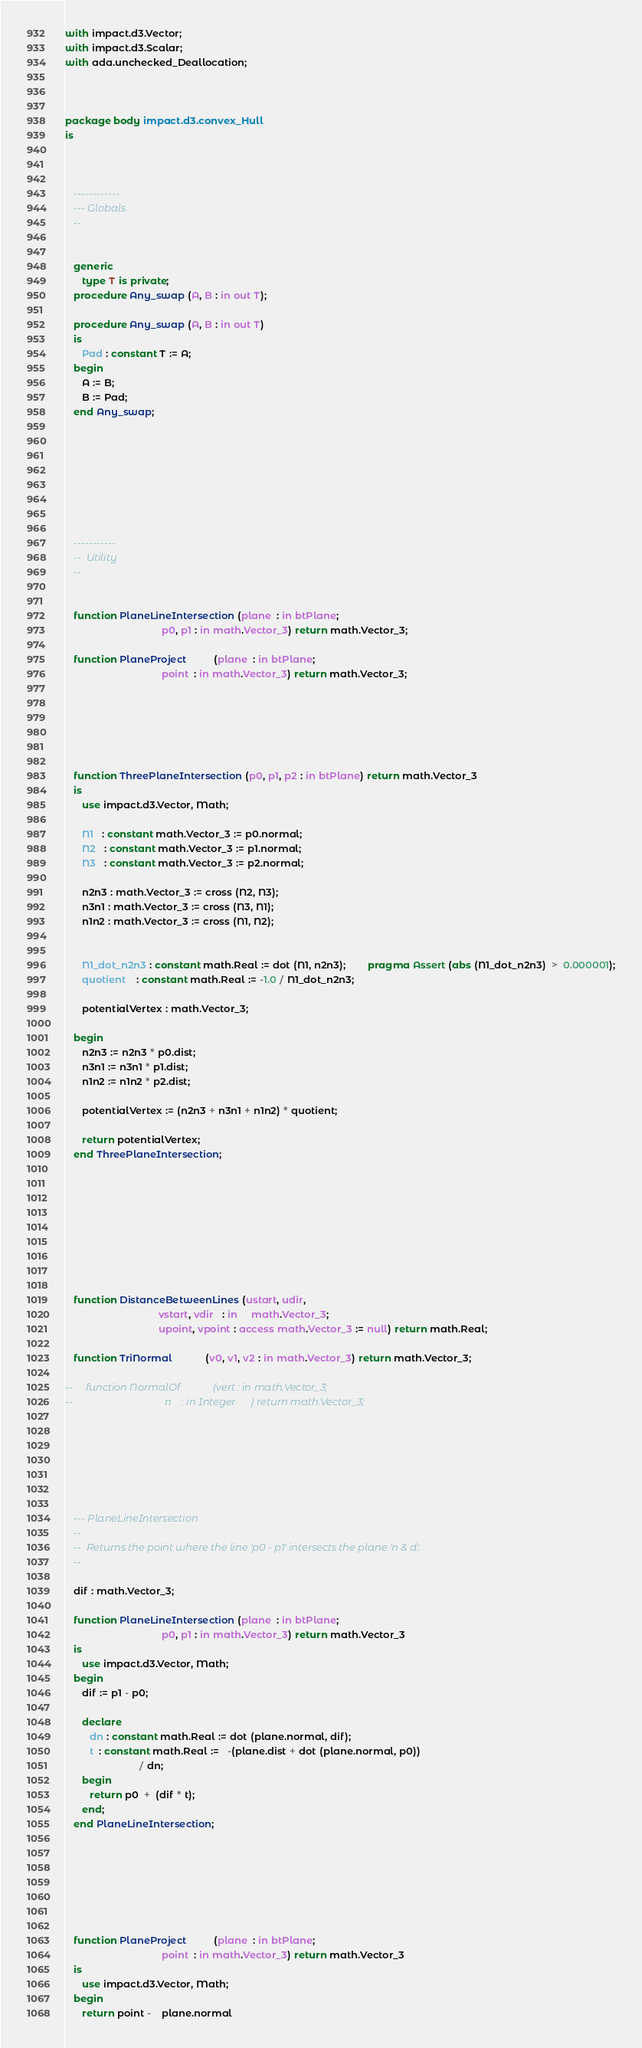Convert code to text. <code><loc_0><loc_0><loc_500><loc_500><_Ada_>with impact.d3.Vector;
with impact.d3.Scalar;
with ada.unchecked_Deallocation;



package body impact.d3.convex_Hull
is



   ------------
   --- Globals
   --


   generic
      type T is private;
   procedure Any_swap (A, B : in out T);

   procedure Any_swap (A, B : in out T)
   is
      Pad : constant T := A;
   begin
      A := B;
      B := Pad;
   end Any_swap;








   -----------
   --  Utility
   --


   function PlaneLineIntersection (plane  : in btPlane;
                                   p0, p1 : in math.Vector_3) return math.Vector_3;

   function PlaneProject          (plane  : in btPlane;
                                   point  : in math.Vector_3) return math.Vector_3;






   function ThreePlaneIntersection (p0, p1, p2 : in btPlane) return math.Vector_3
   is
      use impact.d3.Vector, Math;

      N1   : constant math.Vector_3 := p0.normal;
      N2   : constant math.Vector_3 := p1.normal;
      N3   : constant math.Vector_3 := p2.normal;

      n2n3 : math.Vector_3 := cross (N2, N3);
      n3n1 : math.Vector_3 := cross (N3, N1);
      n1n2 : math.Vector_3 := cross (N1, N2);


      N1_dot_n2n3 : constant math.Real := dot (N1, n2n3);        pragma Assert (abs (N1_dot_n2n3)  >  0.000001);
      quotient    : constant math.Real := -1.0 / N1_dot_n2n3;

      potentialVertex : math.Vector_3;

   begin
      n2n3 := n2n3 * p0.dist;
      n3n1 := n3n1 * p1.dist;
      n1n2 := n1n2 * p2.dist;

      potentialVertex := (n2n3 + n3n1 + n1n2) * quotient;

      return potentialVertex;
   end ThreePlaneIntersection;









   function DistanceBetweenLines (ustart, udir,
                                  vstart, vdir   : in     math.Vector_3;
                                  upoint, vpoint : access math.Vector_3 := null) return math.Real;

   function TriNormal            (v0, v1, v2 : in math.Vector_3) return math.Vector_3;

--     function NormalOf             (vert : in math.Vector_3;
--                                    n    : in Integer      ) return math.Vector_3;







   --- PlaneLineIntersection
   --
   --  Returns the point where the line 'p0 - p1' intersects the plane 'n & d'.
   --

   dif : math.Vector_3;

   function PlaneLineIntersection (plane  : in btPlane;
                                   p0, p1 : in math.Vector_3) return math.Vector_3
   is
      use impact.d3.Vector, Math;
   begin
      dif := p1 - p0;

      declare
         dn : constant math.Real := dot (plane.normal, dif);
         t  : constant math.Real :=   -(plane.dist + dot (plane.normal, p0))
                           / dn;
      begin
         return p0  +  (dif * t);
      end;
   end PlaneLineIntersection;







   function PlaneProject          (plane  : in btPlane;
                                   point  : in math.Vector_3) return math.Vector_3
   is
      use impact.d3.Vector, Math;
   begin
      return point -    plane.normal</code> 